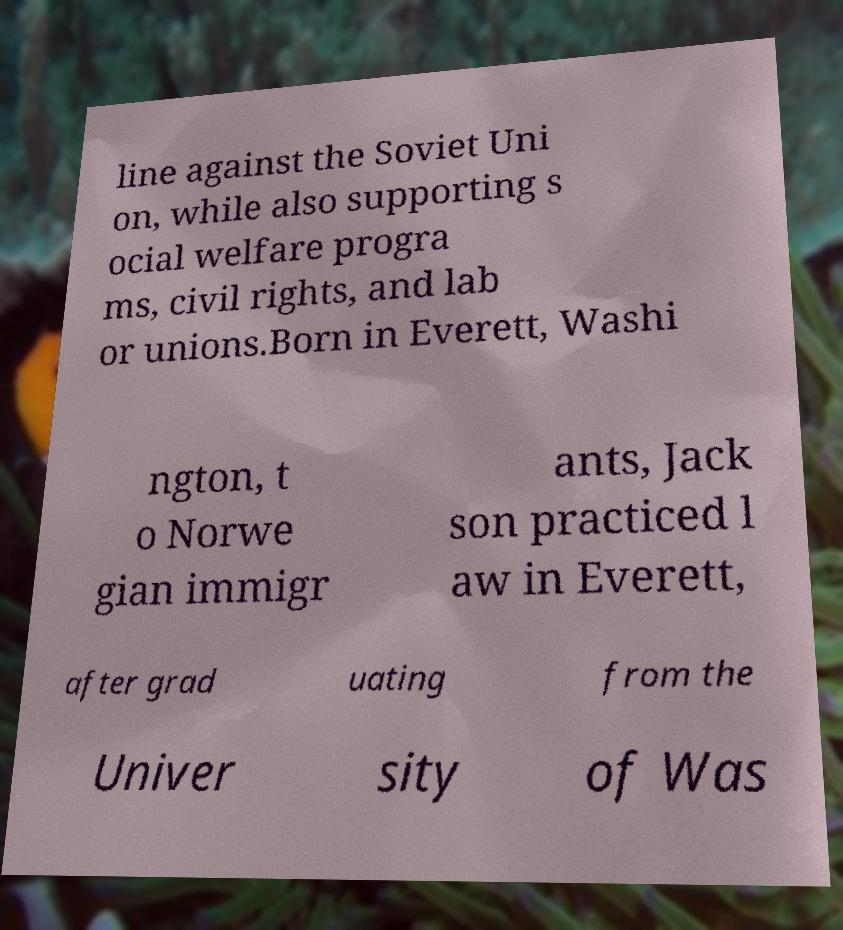Can you accurately transcribe the text from the provided image for me? line against the Soviet Uni on, while also supporting s ocial welfare progra ms, civil rights, and lab or unions.Born in Everett, Washi ngton, t o Norwe gian immigr ants, Jack son practiced l aw in Everett, after grad uating from the Univer sity of Was 